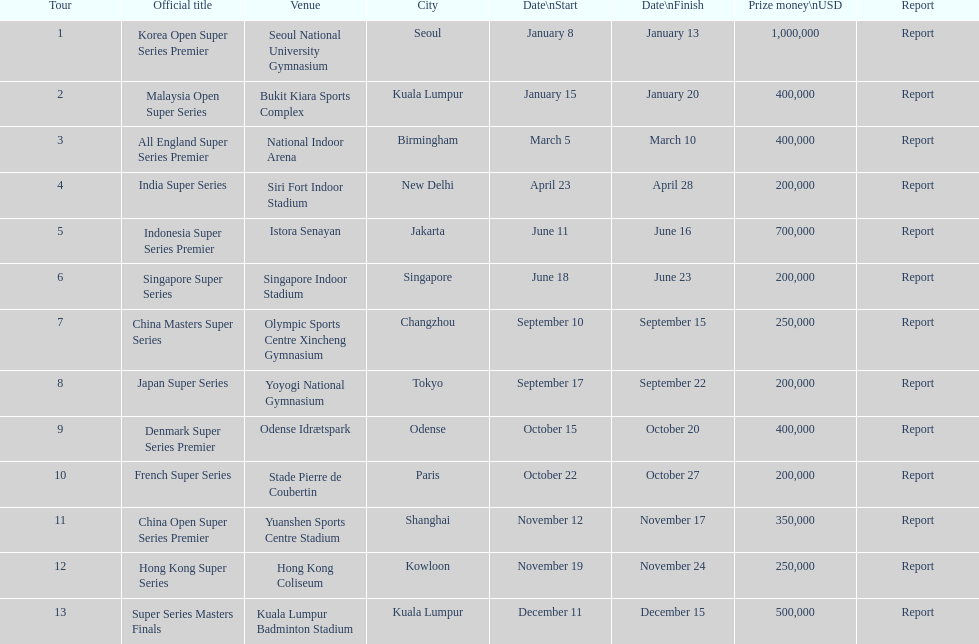In terms of prize money, how does the malaysia open super series compare to the french super series - is it more or less? More. 